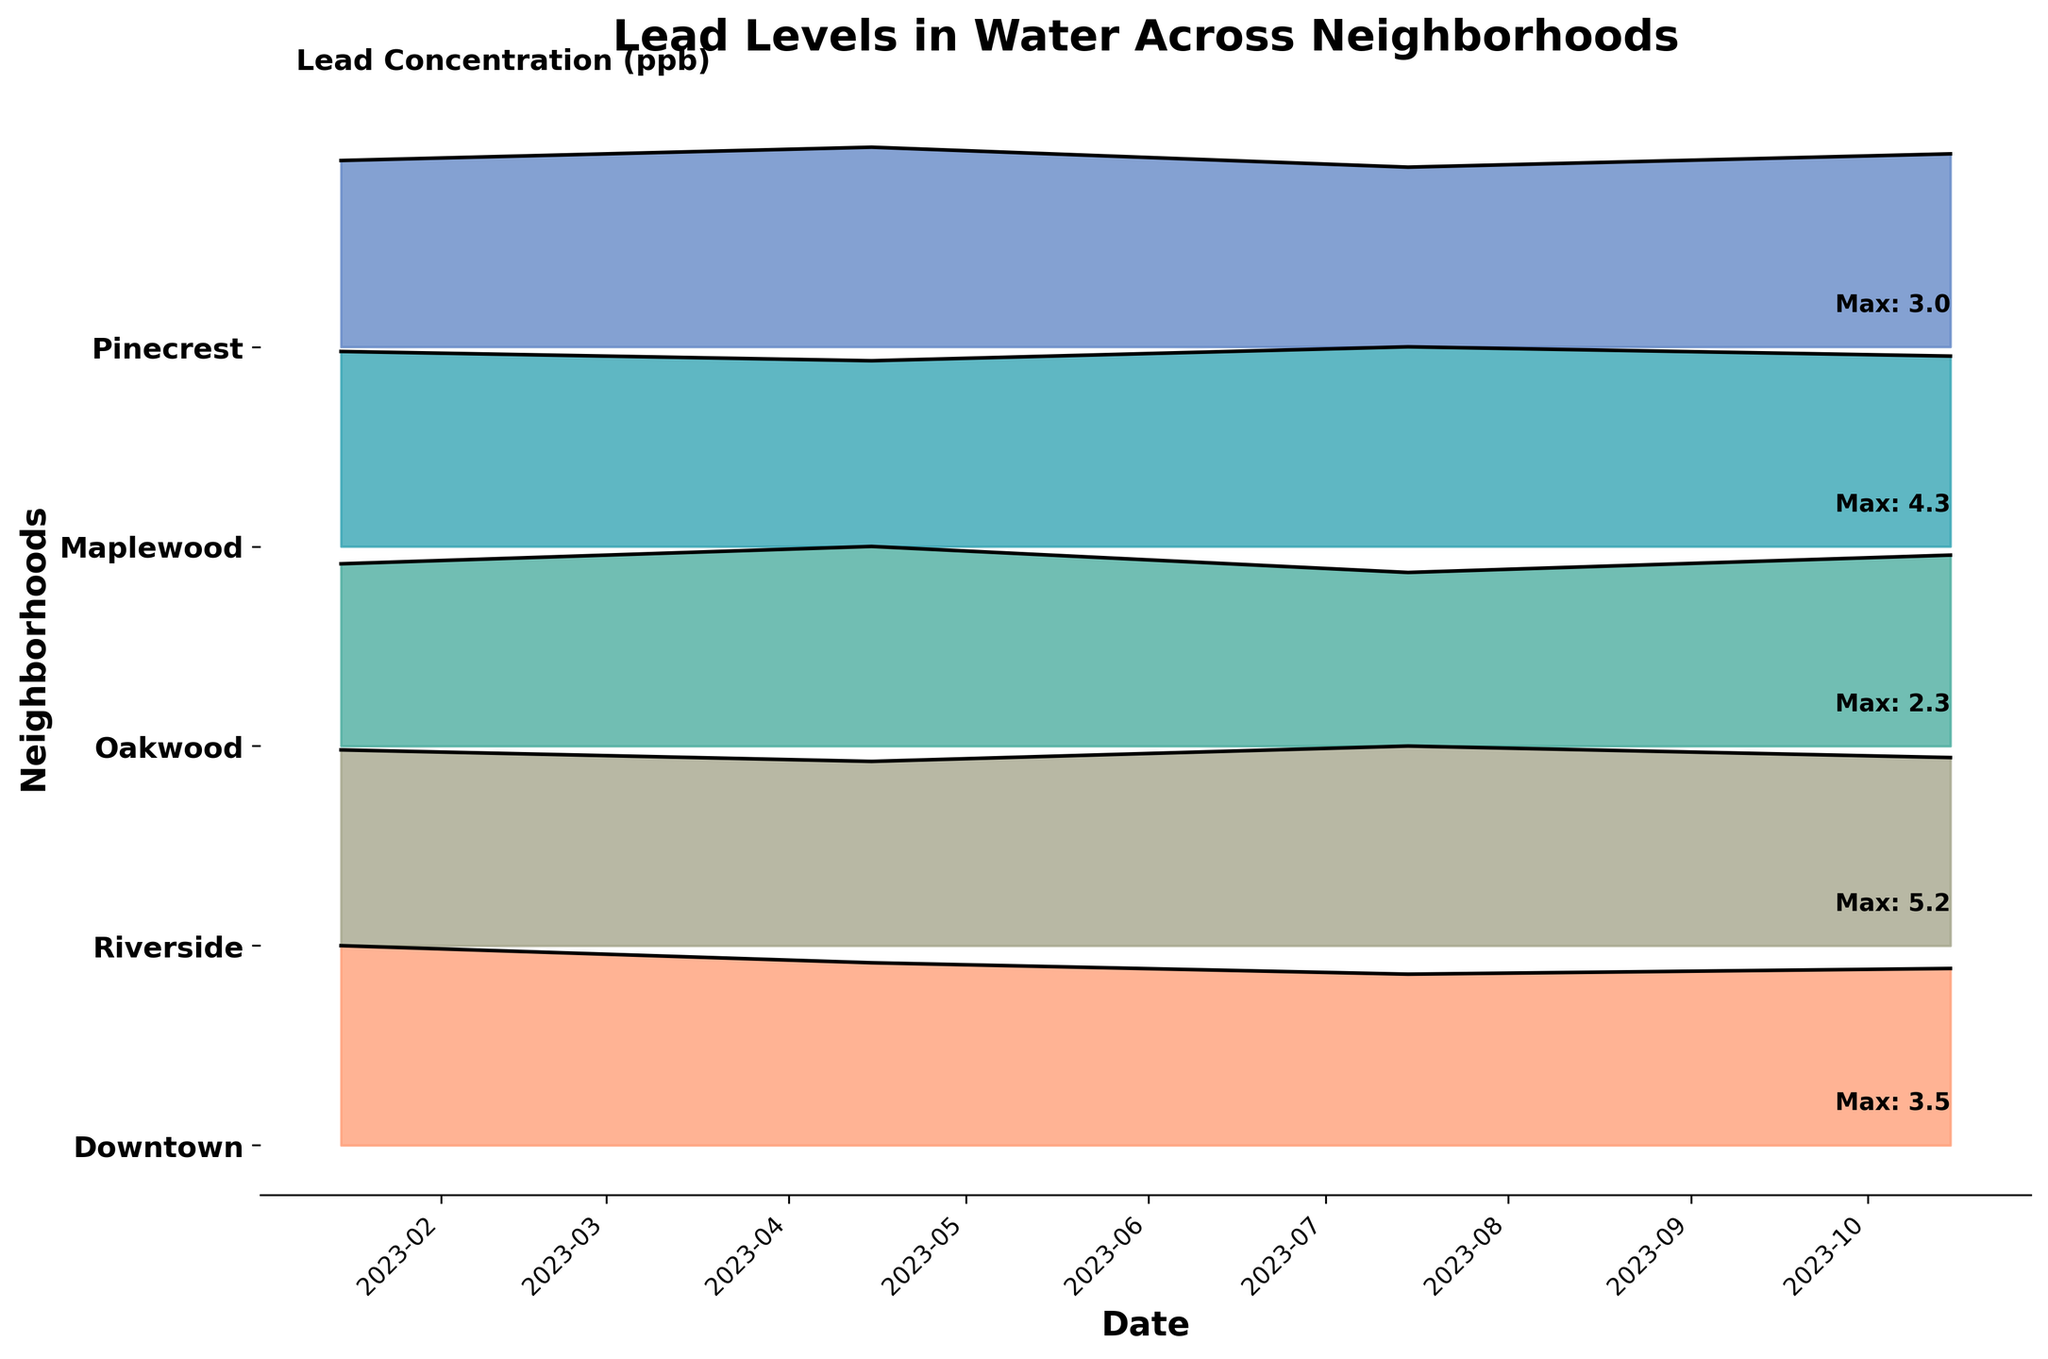what is the title of the figure? The title is typically displayed at the top of the plot and gives an overview of what the plot represents. In this case, the title is "Lead Levels in Water Across Neighborhoods".
Answer: Lead Levels in Water Across Neighborhoods Which neighborhood had the highest maximum lead level? To determine this, look at the text annotations along the y-axis of the plot. The "Max" values for each neighborhood indicate the highest lead level recorded. The maximum values show Riverside has the highest maximum lead level (5.2 ppb).
Answer: Riverside How do the lead levels of Downtown compare from January to July 2023? By visually tracking the lines and shaded areas for Downtown from January to July, we see a decreasing trend in lead levels from 3.5 ppb in January to 3.0 ppb in July.
Answer: They decreased from 3.5 ppb to 3.0 ppb Which neighborhood shows the least variation in lead levels over the dates provided? To find this, visually assess which neighborhood has the most consistent height of the ridgeline plot. Oakwood's plot appears very consistent with lead levels around 2.0-2.3 ppb, indicating minimal variation.
Answer: Oakwood What trend do we observe in Maplewood's lead levels in the water from January to October 2023? Tracking the Maplewood line from January to October, we see that lead levels first increase slightly and then decrease back to the initial level.
Answer: Small increase and then decrease Do Pinecrest lead levels consistently decrease, increase, or fluctuate throughout 2023? Pinecrest's line shows fluctuations: it increases from January to July and then decreases slightly by October.
Answer: Fluctuate What is the maximum lead value recorded for Pinecrest? The text annotations next to the Pinecrest ridgeline provide the "Max" value, which is 3.0 ppb.
Answer: 3.0 ppb Between January and October 2023, which month recorded the highest lead levels across all neighborhoods? Observe the height of the ridgeline peaks in January and October across all neighborhoods. January has the highest point in Riverside (5.1 ppb), more than any other month.
Answer: January In which neighborhood do the maximum lead levels from January to October 2023 most consistently stay below 3.0 ppb? By examining the max lead level annotations, Oakwood consistently has maximum values below 3.0 ppb (2.0-2.3 ppb).
Answer: Oakwood Comparing Riverside and Maplewood, which neighborhood appears to have more stable lead levels throughout the year? Observe the ridgeline peaks and valleys; Riverside shows more fluctuation, while Maplewood has more stable levels with slight variations around 4.0-4.3 ppb.
Answer: Maplewood 